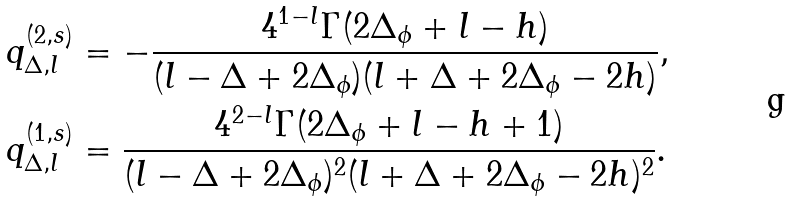<formula> <loc_0><loc_0><loc_500><loc_500>q ^ { ( 2 , s ) } _ { \Delta , l } & = - \frac { 4 ^ { 1 - l } \Gamma ( 2 \Delta _ { \phi } + l - h ) } { ( l - \Delta + 2 \Delta _ { \phi } ) ( l + \Delta + 2 \Delta _ { \phi } - 2 h ) } , \\ q ^ { ( 1 , s ) } _ { \Delta , l } & = \frac { 4 ^ { 2 - l } \Gamma ( 2 \Delta _ { \phi } + l - h + 1 ) } { ( l - \Delta + 2 \Delta _ { \phi } ) ^ { 2 } ( l + \Delta + 2 \Delta _ { \phi } - 2 h ) ^ { 2 } } .</formula> 